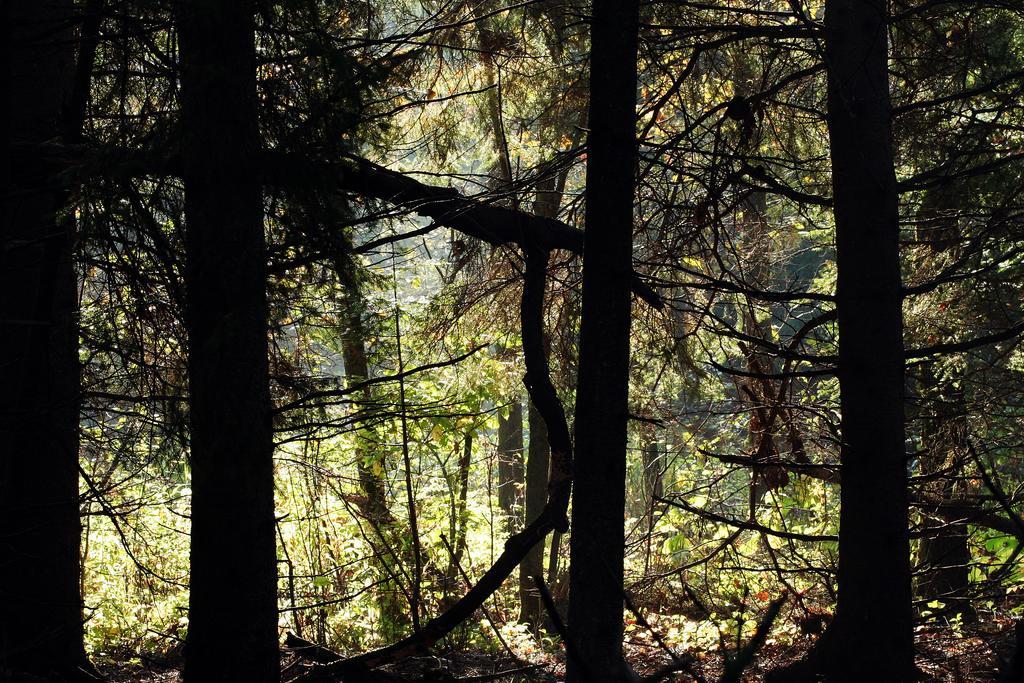How would you summarize this image in a sentence or two? The image might be clicked in the forest. In the picture there are trees, plants and dry leaves. The sun is shining. 